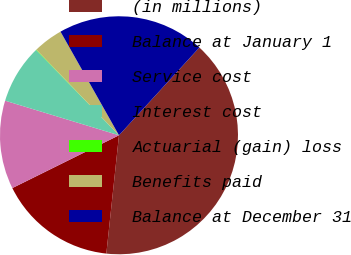Convert chart. <chart><loc_0><loc_0><loc_500><loc_500><pie_chart><fcel>(in millions)<fcel>Balance at January 1<fcel>Service cost<fcel>Interest cost<fcel>Actuarial (gain) loss<fcel>Benefits paid<fcel>Balance at December 31<nl><fcel>39.89%<fcel>15.99%<fcel>12.01%<fcel>8.03%<fcel>0.06%<fcel>4.04%<fcel>19.98%<nl></chart> 